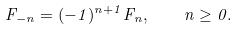Convert formula to latex. <formula><loc_0><loc_0><loc_500><loc_500>F _ { - n } = ( - 1 ) ^ { n + 1 } F _ { n } , \quad n \geq 0 .</formula> 